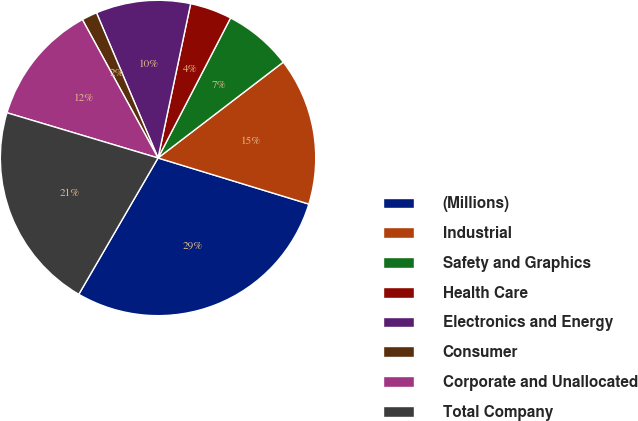Convert chart. <chart><loc_0><loc_0><loc_500><loc_500><pie_chart><fcel>(Millions)<fcel>Industrial<fcel>Safety and Graphics<fcel>Health Care<fcel>Electronics and Energy<fcel>Consumer<fcel>Corporate and Unallocated<fcel>Total Company<nl><fcel>28.66%<fcel>15.12%<fcel>7.0%<fcel>4.29%<fcel>9.7%<fcel>1.58%<fcel>12.41%<fcel>21.25%<nl></chart> 